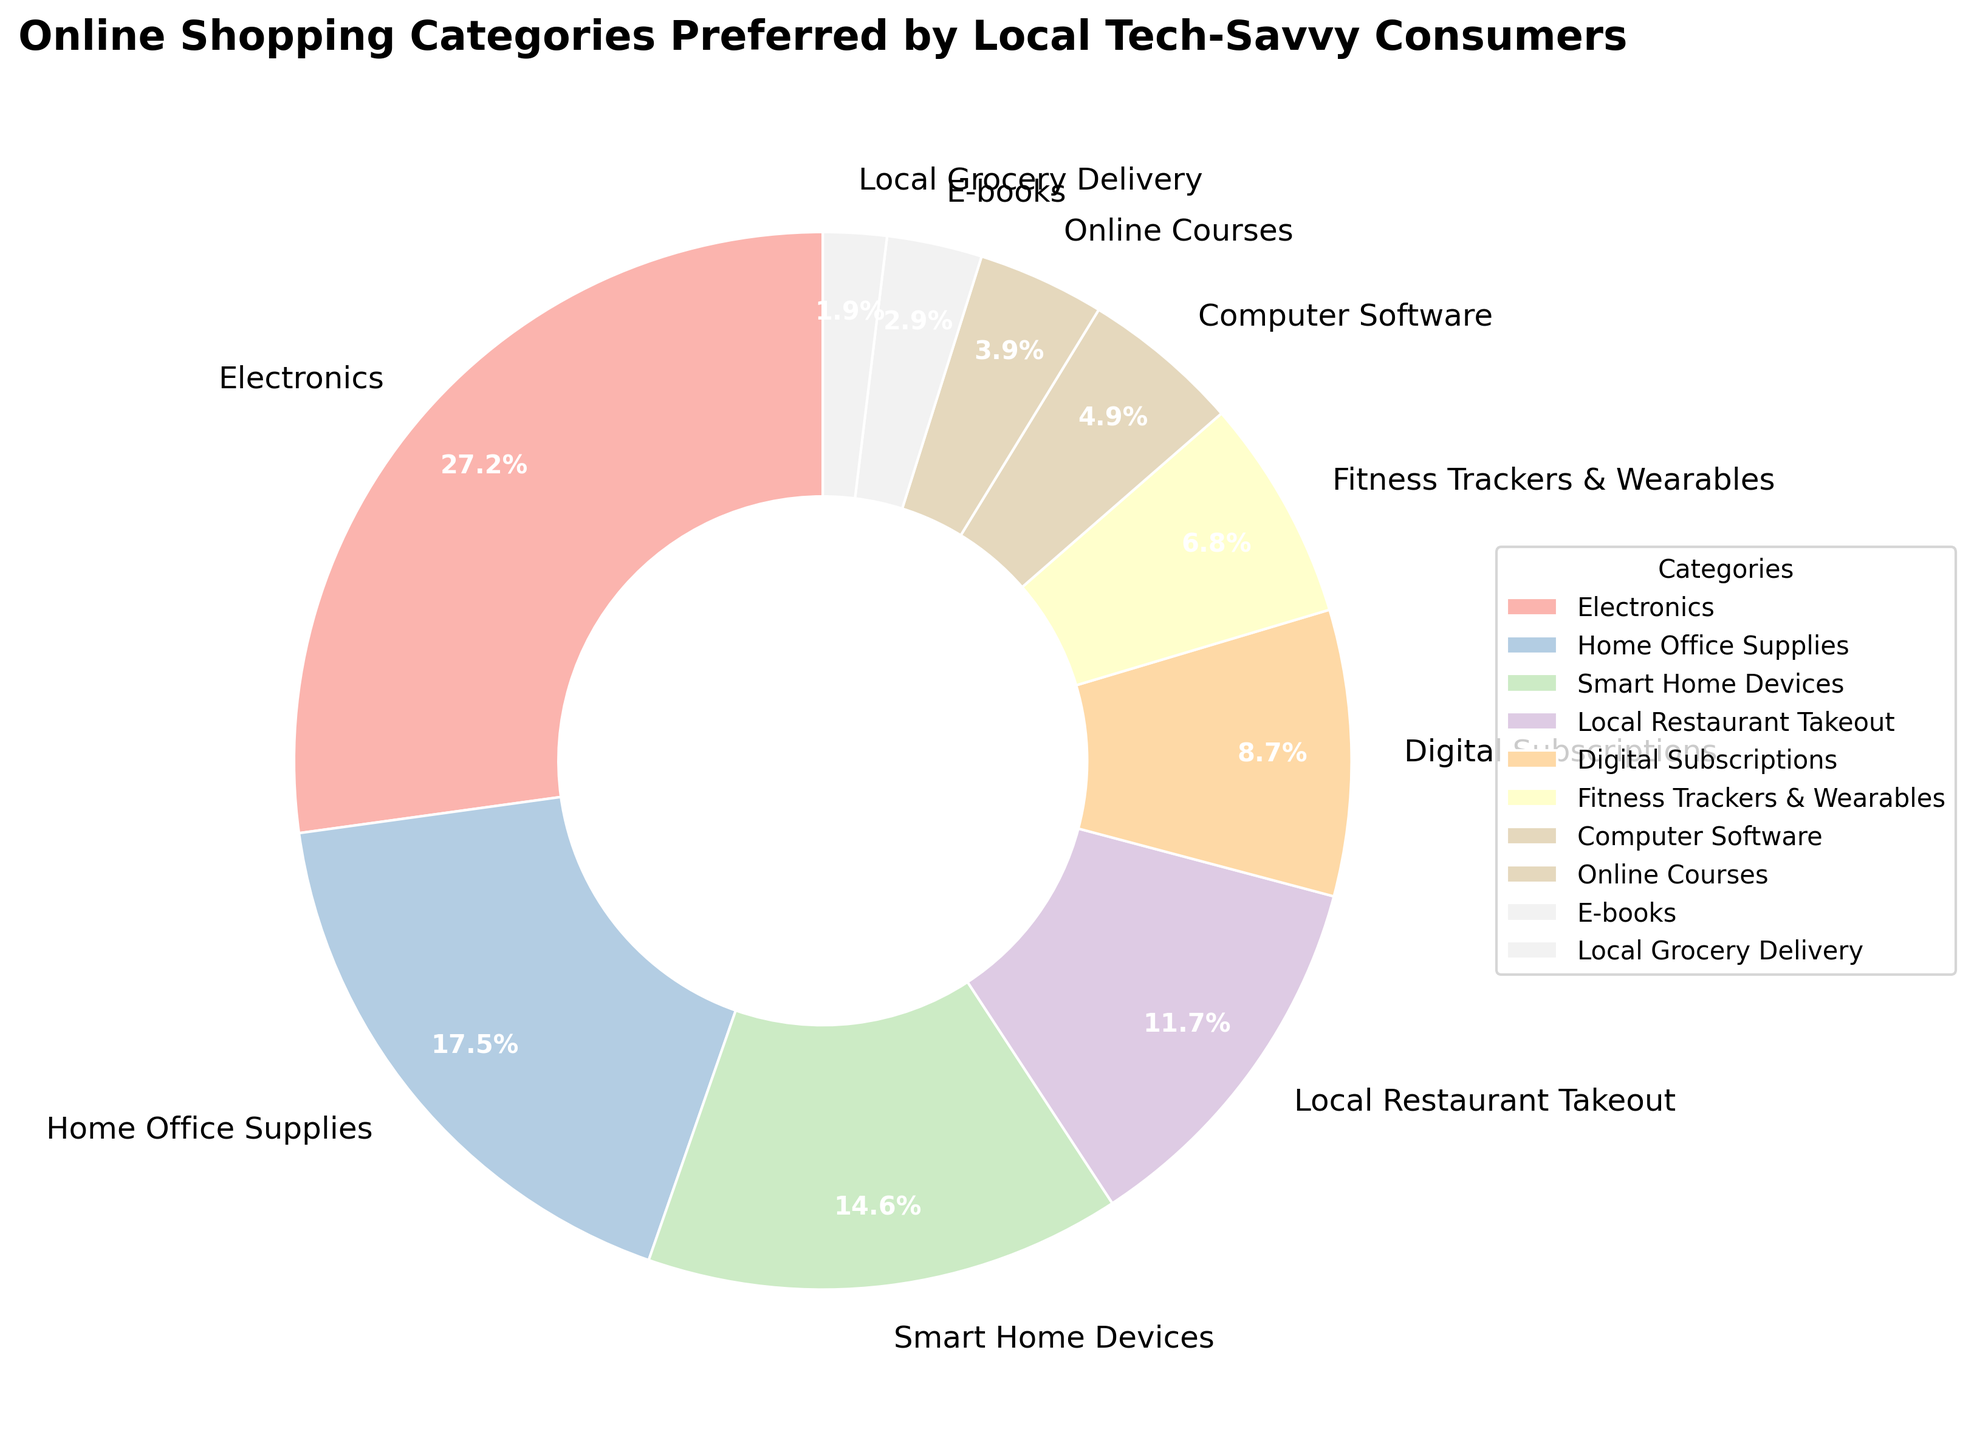What category has the highest percentage of preference? The slice labeled "Electronics" is the largest and shows 28%, which is the highest percentage.
Answer: Electronics What is the total percentage preference for Home Office Supplies and Smart Home Devices combined? The slice for Home Office Supplies is 18% and for Smart Home Devices is 15%. Summing these gives 18% + 15% = 33%.
Answer: 33% Which categories have less than 5% preference each? By looking at the slices with percentages, the categories under 5% are Online Courses with 4%, E-books with 3%, and Local Grocery Delivery with 2%.
Answer: Online Courses, E-books, Local Grocery Delivery How much more preferred are Electronics compared to Local Restaurant Takeout? The slice for Electronics is 28% and Local Restaurant Takeout is 12%. Subtracting these gives 28% - 12% = 16%.
Answer: 16% Are there more people preferring Digital Subscriptions or Fitness Trackers & Wearables? The slice for Digital Subscriptions is 9%, while for Fitness Trackers & Wearables it is 7%. Thus, more people prefer Digital Subscriptions.
Answer: Digital Subscriptions Which category has the smallest percentage of preference? The slice labeled "Local Grocery Delivery" is the smallest and shows 2%, which is the smallest percentage.
Answer: Local Grocery Delivery If you combined the categories of Digital Subscriptions and Computer Software, would they make up more than the preference for Home Office Supplies? The slice for Digital Subscriptions is 9% and for Computer Software is 5%. Adding these gives 9% + 5% = 14%. Home Office Supplies is 18%. 14% is less than 18%, so the combined preference would not exceed Home Office Supplies.
Answer: No What is the difference in preference between Fitness Trackers & Wearables and Online Courses? The slice for Fitness Trackers & Wearables is 7% and for Online Courses is 4%. Subtracting these gives 7% - 4% = 3%.
Answer: 3% 